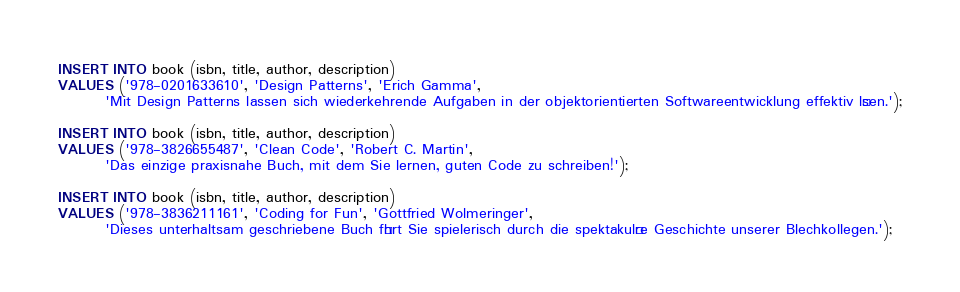Convert code to text. <code><loc_0><loc_0><loc_500><loc_500><_SQL_>INSERT INTO book (isbn, title, author, description)
VALUES ('978-0201633610', 'Design Patterns', 'Erich Gamma',
        'Mit Design Patterns lassen sich wiederkehrende Aufgaben in der objektorientierten Softwareentwicklung effektiv lösen.');

INSERT INTO book (isbn, title, author, description)
VALUES ('978-3826655487', 'Clean Code', 'Robert C. Martin',
        'Das einzige praxisnahe Buch, mit dem Sie lernen, guten Code zu schreiben!');

INSERT INTO book (isbn, title, author, description)
VALUES ('978-3836211161', 'Coding for Fun', 'Gottfried Wolmeringer',
        'Dieses unterhaltsam geschriebene Buch führt Sie spielerisch durch die spektakuläre Geschichte unserer Blechkollegen.');
</code> 